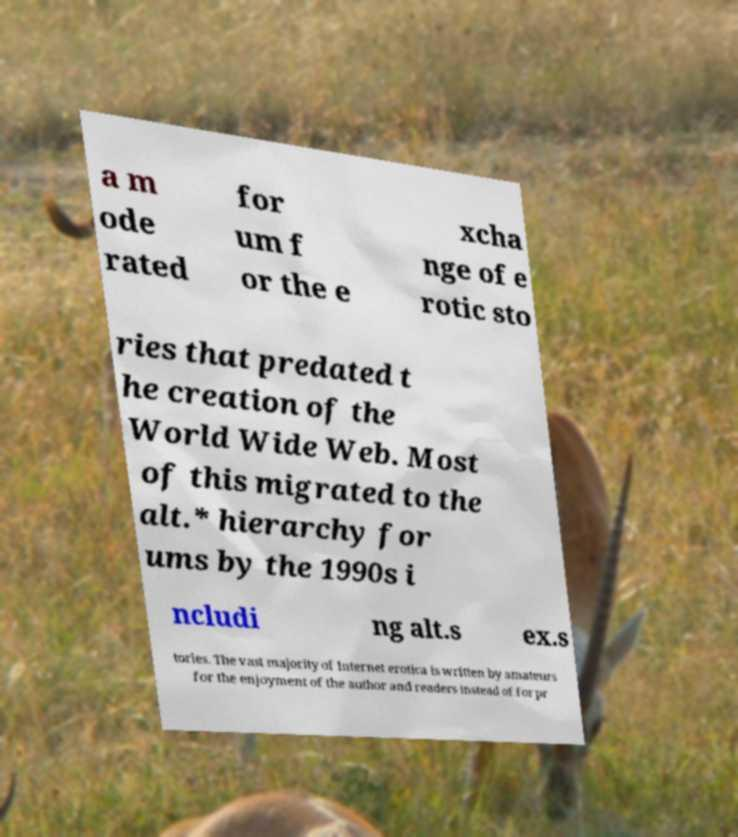Can you accurately transcribe the text from the provided image for me? a m ode rated for um f or the e xcha nge of e rotic sto ries that predated t he creation of the World Wide Web. Most of this migrated to the alt.* hierarchy for ums by the 1990s i ncludi ng alt.s ex.s tories. The vast majority of Internet erotica is written by amateurs for the enjoyment of the author and readers instead of for pr 